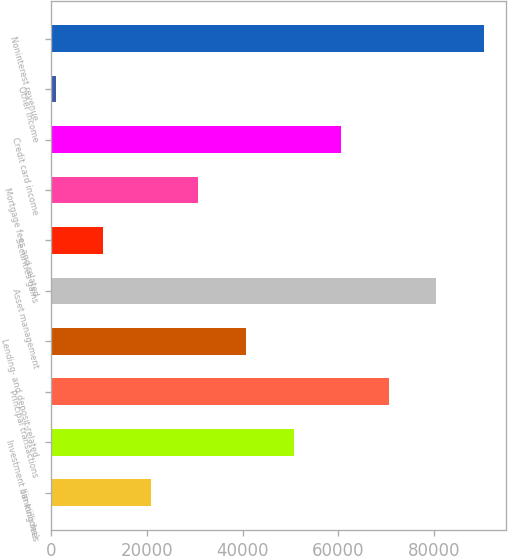Convert chart to OTSL. <chart><loc_0><loc_0><loc_500><loc_500><bar_chart><fcel>(in millions)<fcel>Investment banking fees<fcel>Principal transactions<fcel>Lending- and deposit-related<fcel>Asset management<fcel>Securities gains<fcel>Mortgage fees and related<fcel>Credit card income<fcel>Other income<fcel>Noninterest revenue<nl><fcel>20819.6<fcel>50675<fcel>70578.6<fcel>40723.2<fcel>80530.4<fcel>10867.8<fcel>30771.4<fcel>60626.8<fcel>916<fcel>90482.2<nl></chart> 